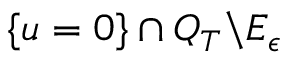<formula> <loc_0><loc_0><loc_500><loc_500>\{ u = 0 \} \cap Q _ { T } \ E _ { \epsilon }</formula> 